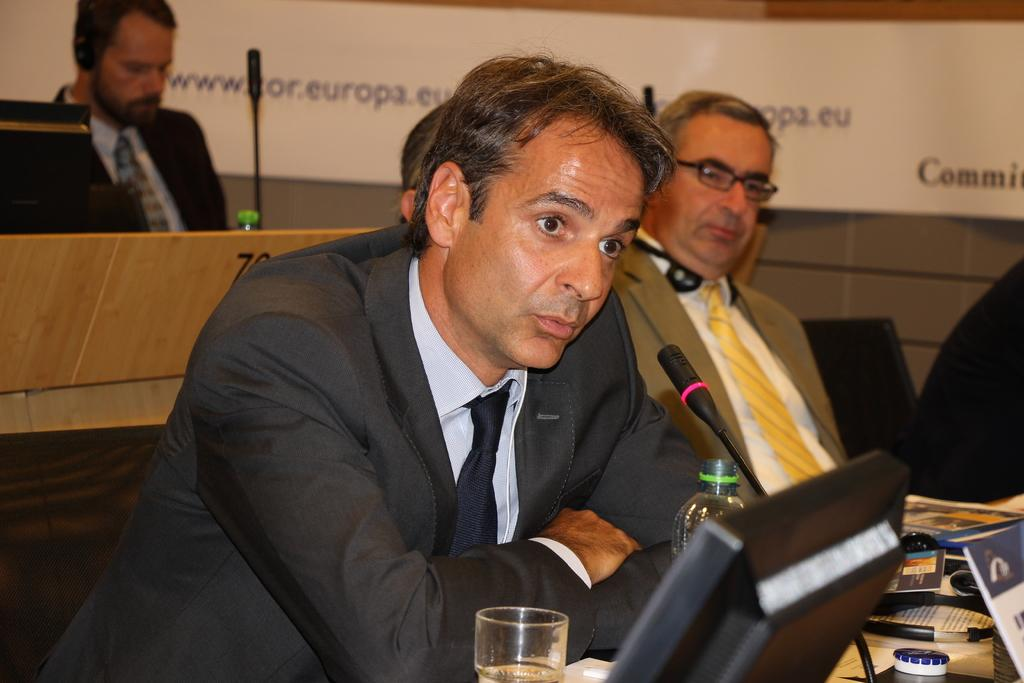How many people are in the group in the image? There is a group of people in the image, but the exact number is not specified. What are the people in the group doing? The people are sitting on chairs in the image. Can you describe the man in the group? There is a man in the group, and in front of him, there is a microphone, a bottle, a glass, a monitor, and some papers. What is the man likely to be doing in the image? The man might be giving a presentation or speech, as he has a microphone and papers in front of him. What can be seen behind the people in the image? There is a wall behind the people in the image. What type of hat is the man wearing in the image? There is no hat visible in the image; the man does not appear to be wearing one. 